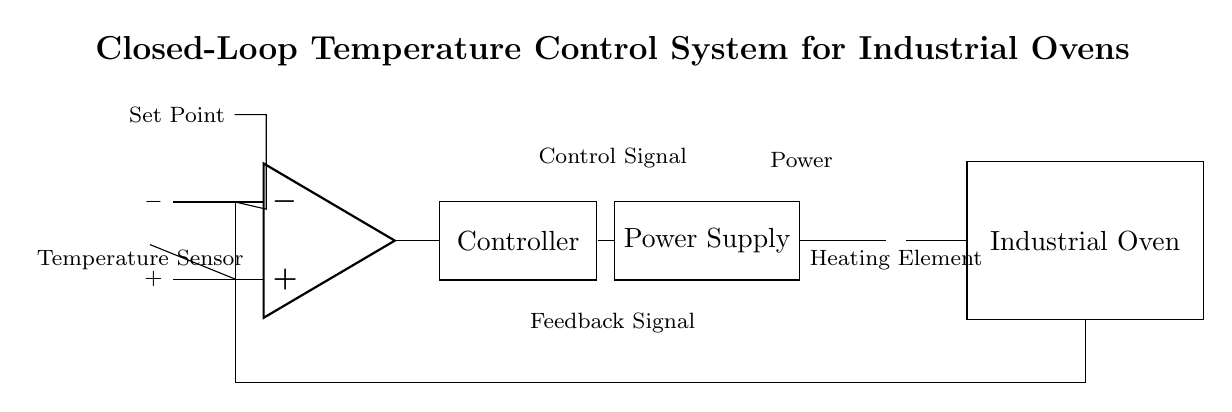What type of sensor is used in this circuit? The diagram shows a temperature sensor represented by a thermocouple symbol. Thermocouples are used for measuring temperature in industrial settings.
Answer: Temperature Sensor What component is used to compare the input and set point temperatures? The op-amp represents the comparator in the circuit, which takes two inputs: the feedback signal from the oven and the set point from the user. It compares these values to generate a control signal.
Answer: Comparator How many main components are present in this circuit? The main components are the temperature sensor, comparator, controller, power supply, heating element, and oven, totaling six key components.
Answer: Six What does the feedback loop connect? The feedback loop connects the oven's output back to the negative input of the comparator, allowing the system to adjust the heating based on the actual temperature inside the oven.
Answer: The oven to the comparator What is the purpose of the controller in this circuit? The controller takes the output signal from the comparator and adjusts the power supplied to the heating element to maintain the desired temperature, functioning as part of the closed-loop system.
Answer: Temperature Regulation What does the set point represent in the circuit? The set point represents the desired temperature that the user wants the oven to maintain. It is the target that the feedback control system strives to achieve.
Answer: Desired Temperature What type of control system is illustrated in this circuit? The circuit illustrates a closed-loop feedback control system, which continuously monitors the output and adjusts inputs based on the difference between desired and actual performance.
Answer: Closed-loop Feedback Control System 